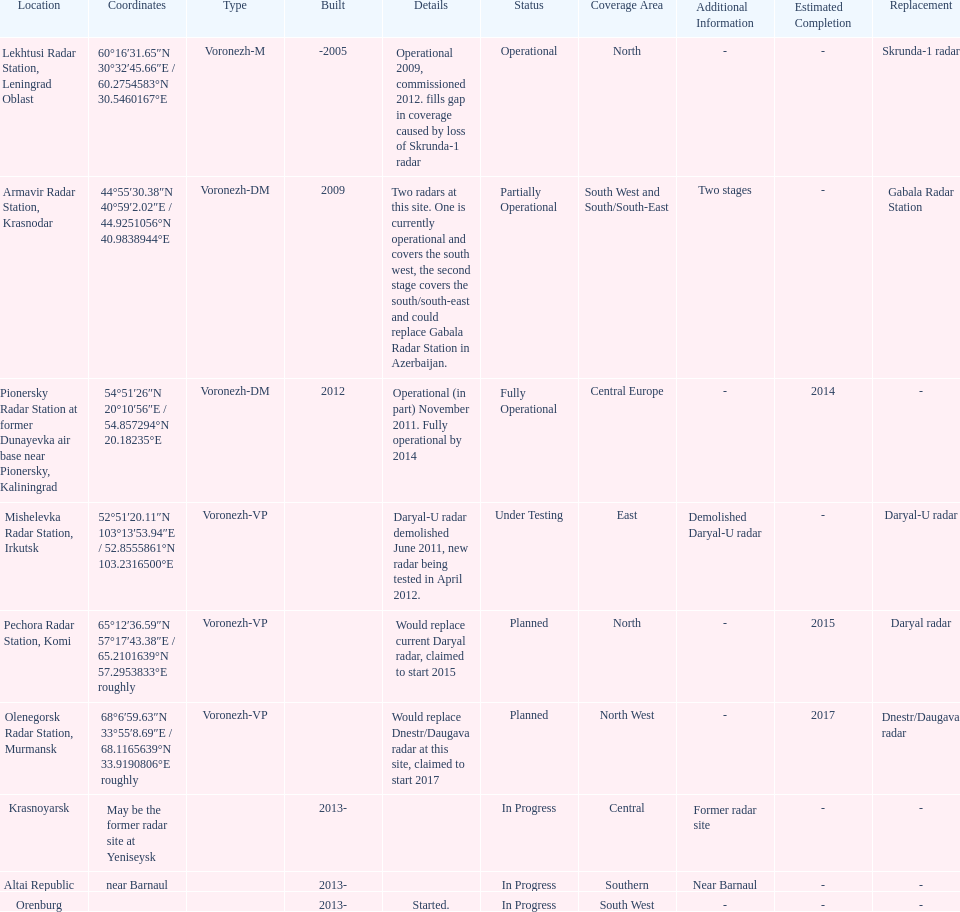How many voronezh radars are in kaliningrad or in krasnodar? 2. 